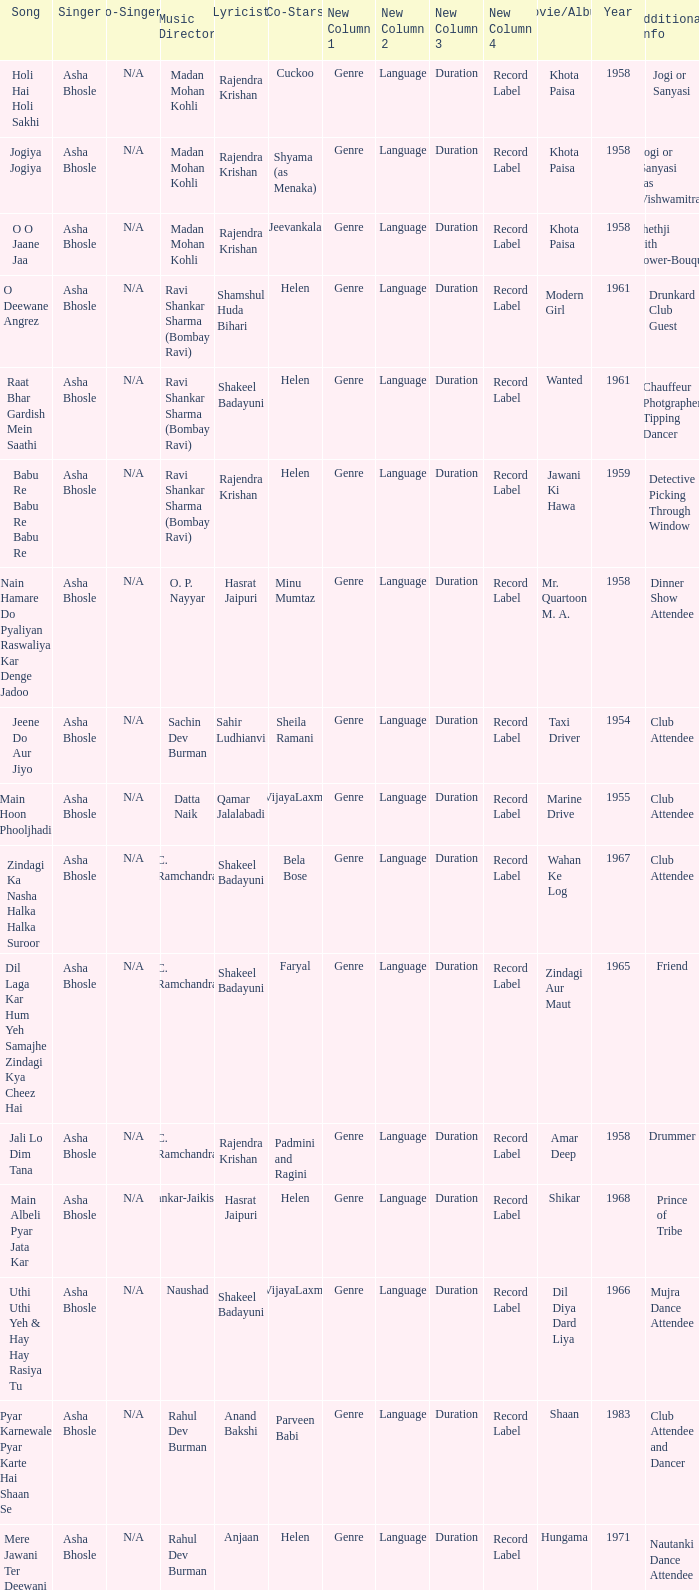What movie did Vijayalaxmi Co-star in and Shakeel Badayuni write the lyrics? Dil Diya Dard Liya. 